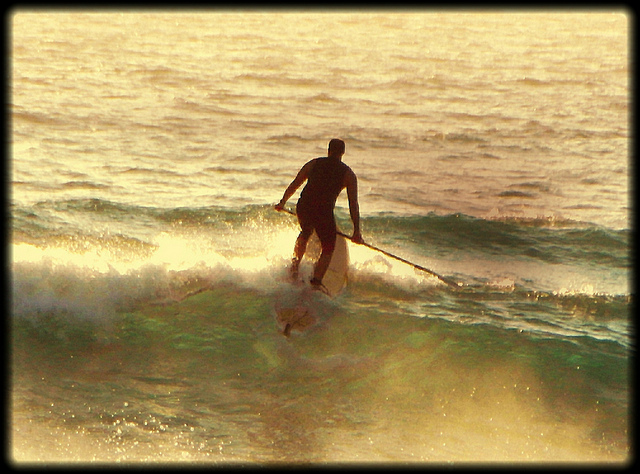Is the man surfing in a group or alone? The man is surfing alone on the water. There are no other surfers or people visible around him, indicating he is enjoying a solitary paddleboarding session. 